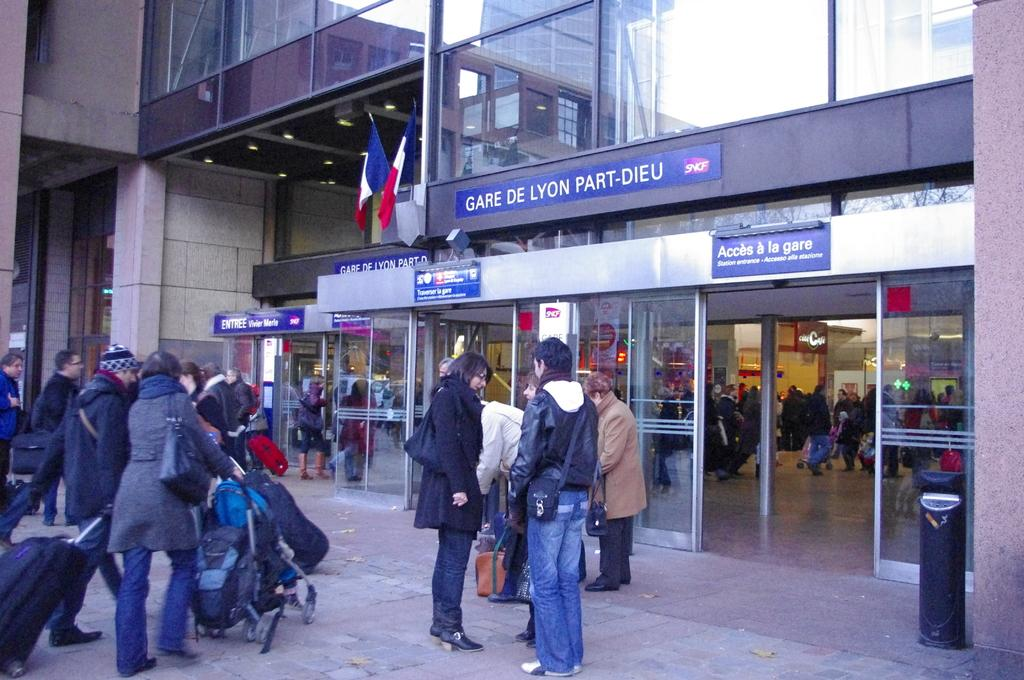Who or what can be seen in the image? There are people in the image. What is visible in the background of the image? There is a building in the background of the image. Can you describe the building in the image? There is text written on the building. How many goats are standing next to the people in the image? There are no goats present in the image. What type of breath do the boys in the image have? There are no boys mentioned in the image, and therefore, we cannot determine the type of breath they might have. 